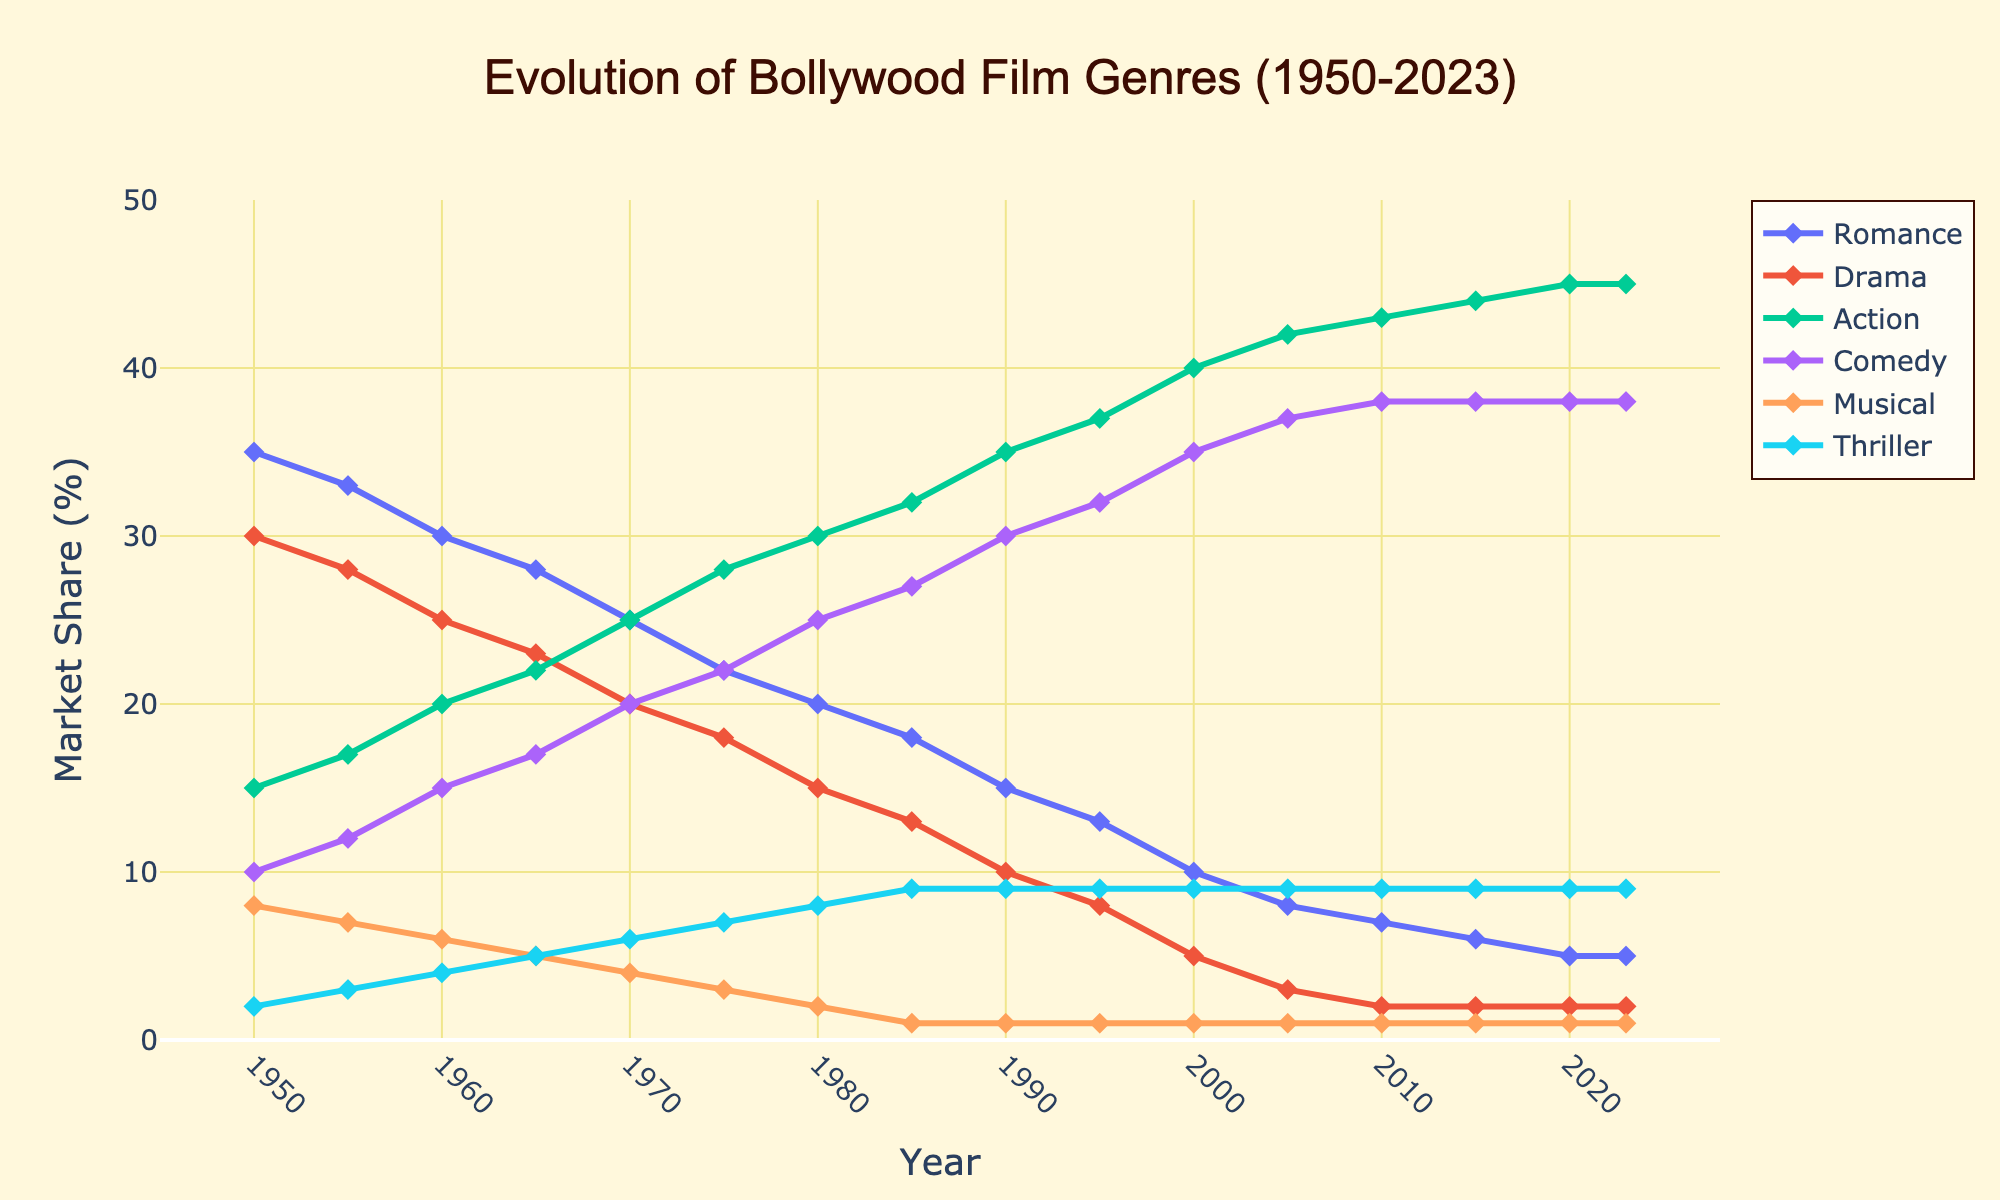How has the market share of Romance films changed from 1950 to 2023? The market share of Romance films in 1950 was 35%. Over the years, this share has consistently decreased, reaching 5% by 2023.
Answer: Decreased from 35% to 5% Which genre saw the highest increase in market share from 1950 to 2023? In 1950, the Action genre had a market share of 15%, and by 2023, it increased to 45%. This is the highest increase among all genres.
Answer: Action During which decade did Comedy films overtake Romance films in market share? In 1970, the market share of Comedy films was 20%, whereas Romance was 25%. By 1975, Comedy films reached 22% while Romance dropped to 22%, marking the overtaking.
Answer: 1970s What is the difference in market share between Drama films and Musical films in 2020? In 2020, the market share of Drama films was 2%, while Musical films also had a 1% share. The difference is 2% - 1% = 1%.
Answer: 1% From the graph, which genres have a stable market share from 2010 to 2023? From 2010 to 2023, the genres with a stable market share are Romance (between 5-6%) and Drama (at 2%).
Answer: Romance and Drama What's the sum of market shares for Action and Comedy films in 2000? In the year 2000, the market share for Action films is 40% and for Comedy films is 35%. The sum is 40% + 35% = 75%.
Answer: 75% In which year did Thrillers reach a market share of 9%? The market share for Thrillers reached 9% in the year 1985 and has remained constant since then.
Answer: 1985 Comparing 1960 and 2023, which genre saw a decrease in market share and by how much? Romance decreased from 30% in 1960 to 5% in 2023. Drama decreased from 25% to 2%. Musicals decreased from 6% to 1%. Comparing the differences, Romance decreased by 25%, Drama by 23%, and Musicals by 5%.
Answer: Romance by 25%, Drama by 23%, and Musicals by 5% 